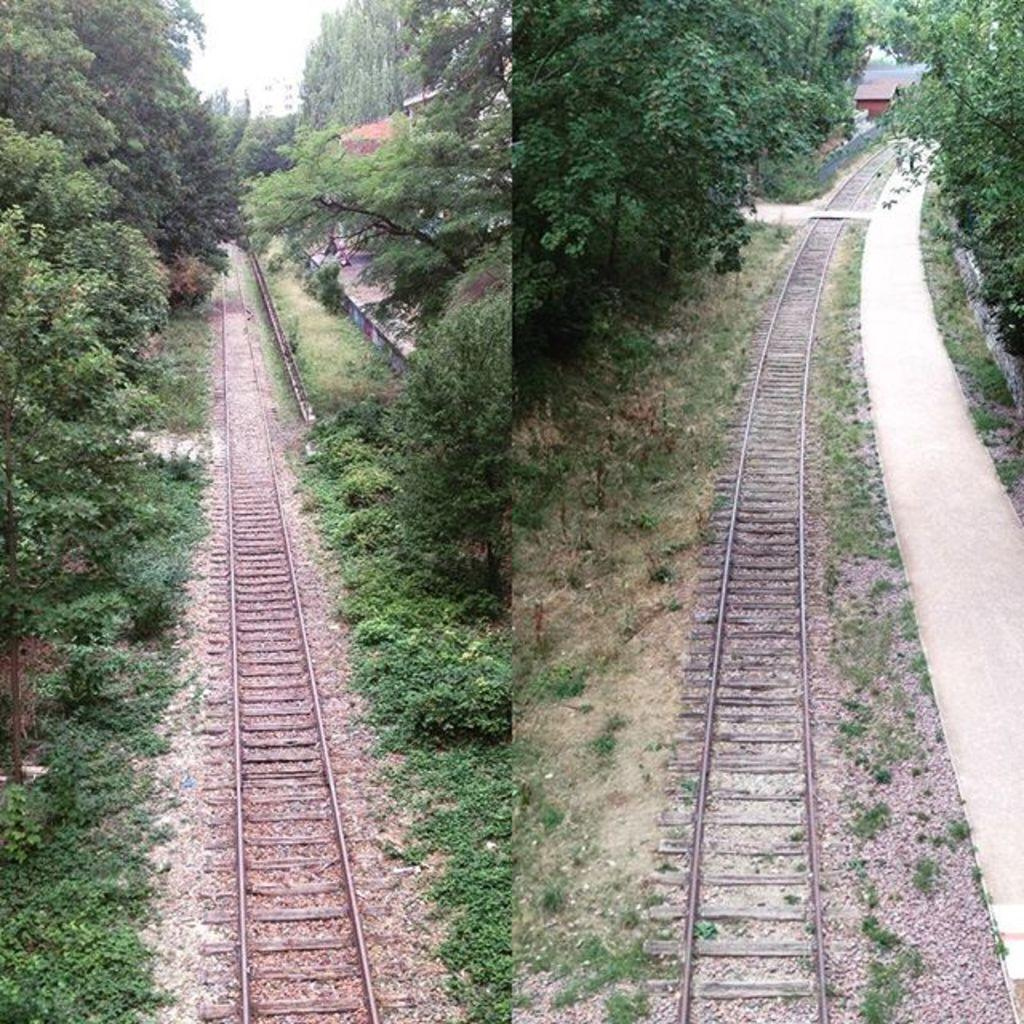What type of picture is in the image? There is a collage picture in the image. What is depicted in the collage picture? The collage picture contains a railway track. What can be seen on the left side of the collage picture? There are trees on the left side of the collage picture. What can be seen on the right side of the collage picture? There are trees on the right side of the collage picture. What type of paper is the collage made of in the image? The facts provided do not mention the type of paper used in the collage, so we cannot determine that information from the image. 